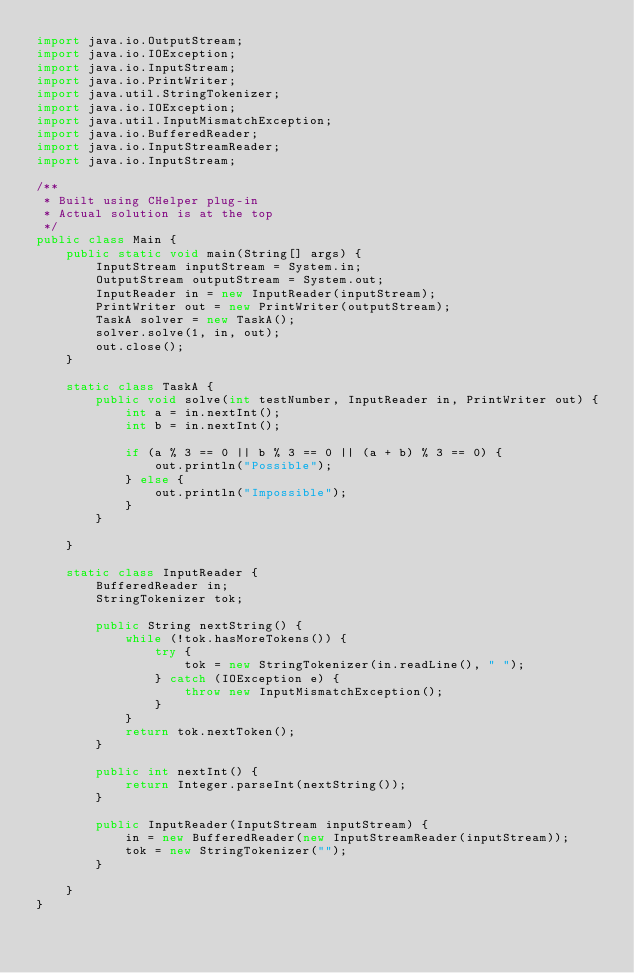Convert code to text. <code><loc_0><loc_0><loc_500><loc_500><_Java_>import java.io.OutputStream;
import java.io.IOException;
import java.io.InputStream;
import java.io.PrintWriter;
import java.util.StringTokenizer;
import java.io.IOException;
import java.util.InputMismatchException;
import java.io.BufferedReader;
import java.io.InputStreamReader;
import java.io.InputStream;

/**
 * Built using CHelper plug-in
 * Actual solution is at the top
 */
public class Main {
    public static void main(String[] args) {
        InputStream inputStream = System.in;
        OutputStream outputStream = System.out;
        InputReader in = new InputReader(inputStream);
        PrintWriter out = new PrintWriter(outputStream);
        TaskA solver = new TaskA();
        solver.solve(1, in, out);
        out.close();
    }

    static class TaskA {
        public void solve(int testNumber, InputReader in, PrintWriter out) {
            int a = in.nextInt();
            int b = in.nextInt();

            if (a % 3 == 0 || b % 3 == 0 || (a + b) % 3 == 0) {
                out.println("Possible");
            } else {
                out.println("Impossible");
            }
        }

    }

    static class InputReader {
        BufferedReader in;
        StringTokenizer tok;

        public String nextString() {
            while (!tok.hasMoreTokens()) {
                try {
                    tok = new StringTokenizer(in.readLine(), " ");
                } catch (IOException e) {
                    throw new InputMismatchException();
                }
            }
            return tok.nextToken();
        }

        public int nextInt() {
            return Integer.parseInt(nextString());
        }

        public InputReader(InputStream inputStream) {
            in = new BufferedReader(new InputStreamReader(inputStream));
            tok = new StringTokenizer("");
        }

    }
}

</code> 